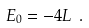<formula> <loc_0><loc_0><loc_500><loc_500>E _ { 0 } = - { 4 } L \ .</formula> 